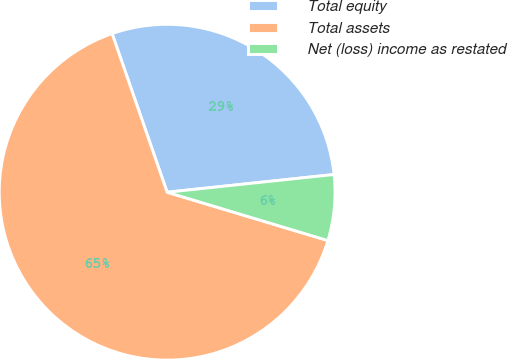Convert chart. <chart><loc_0><loc_0><loc_500><loc_500><pie_chart><fcel>Total equity<fcel>Total assets<fcel>Net (loss) income as restated<nl><fcel>28.63%<fcel>65.03%<fcel>6.33%<nl></chart> 